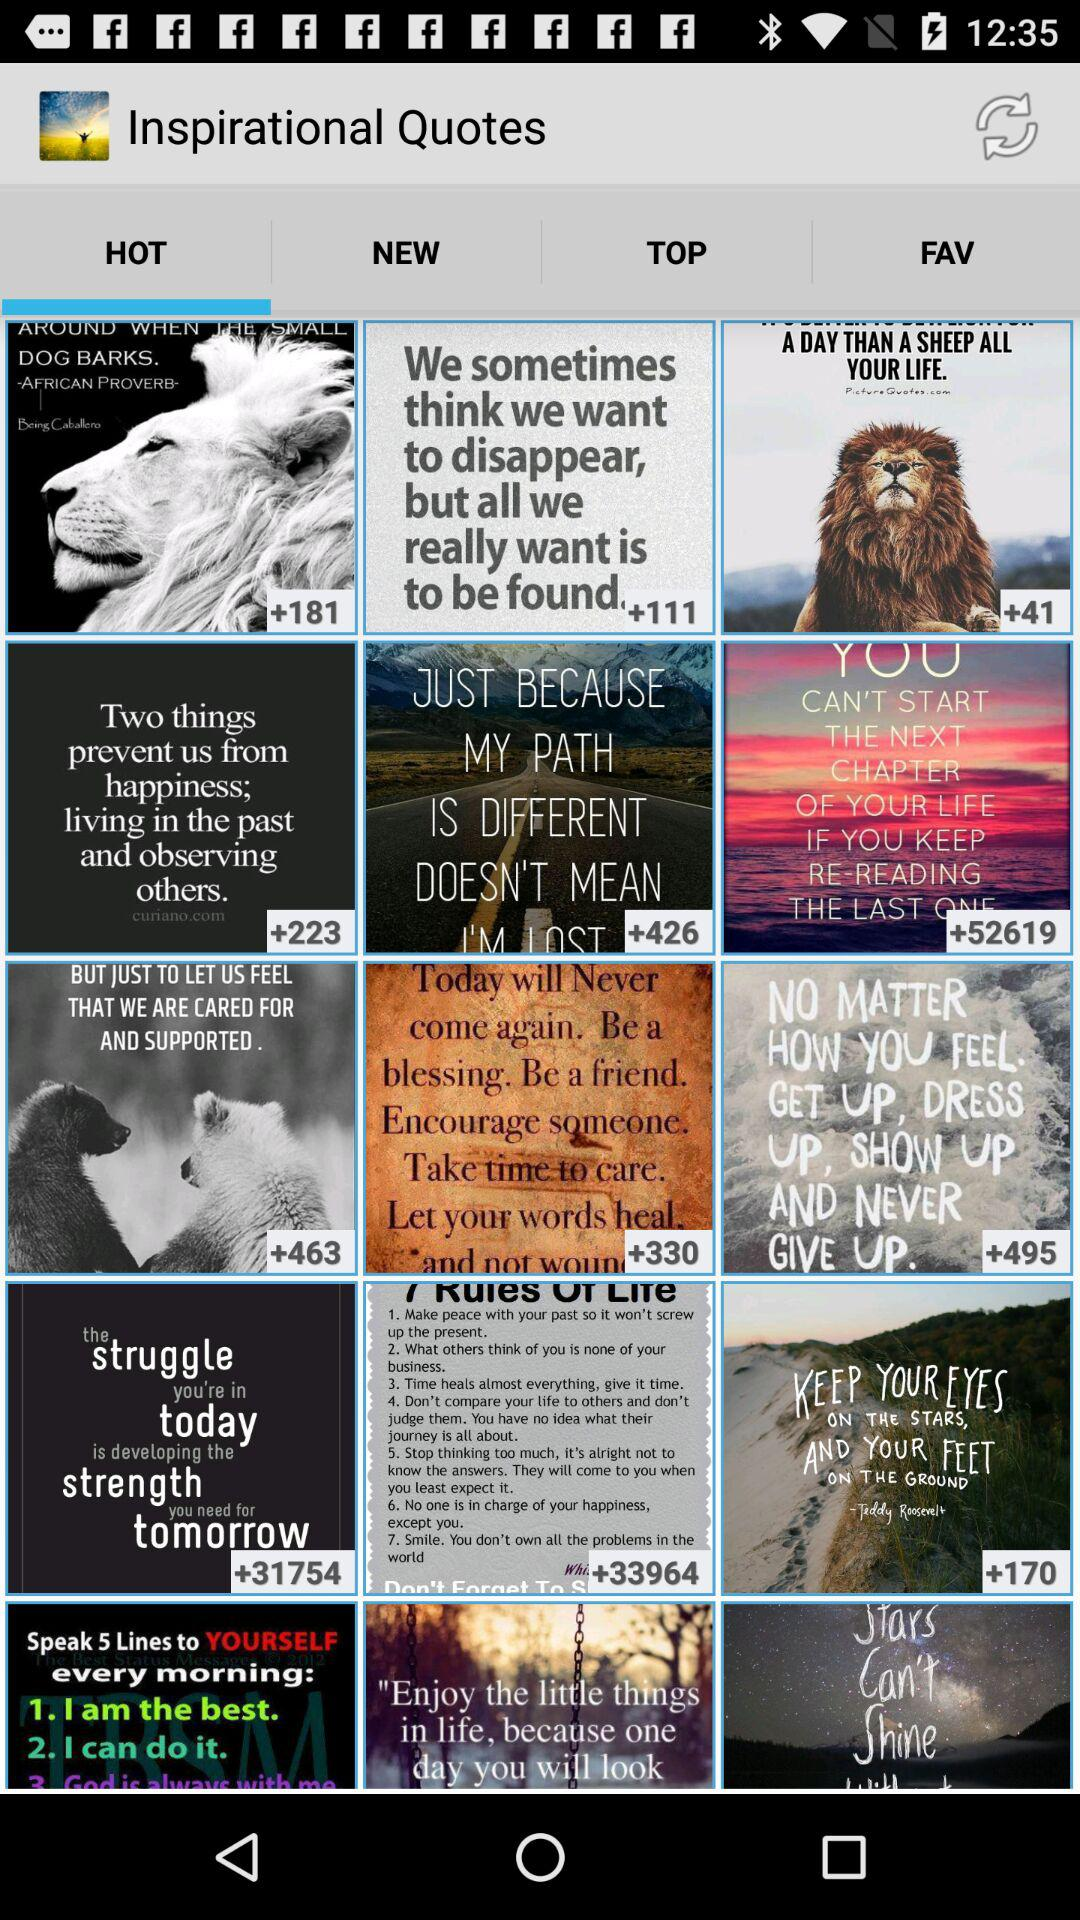Which tab is selected? The selected tab is "HOT". 